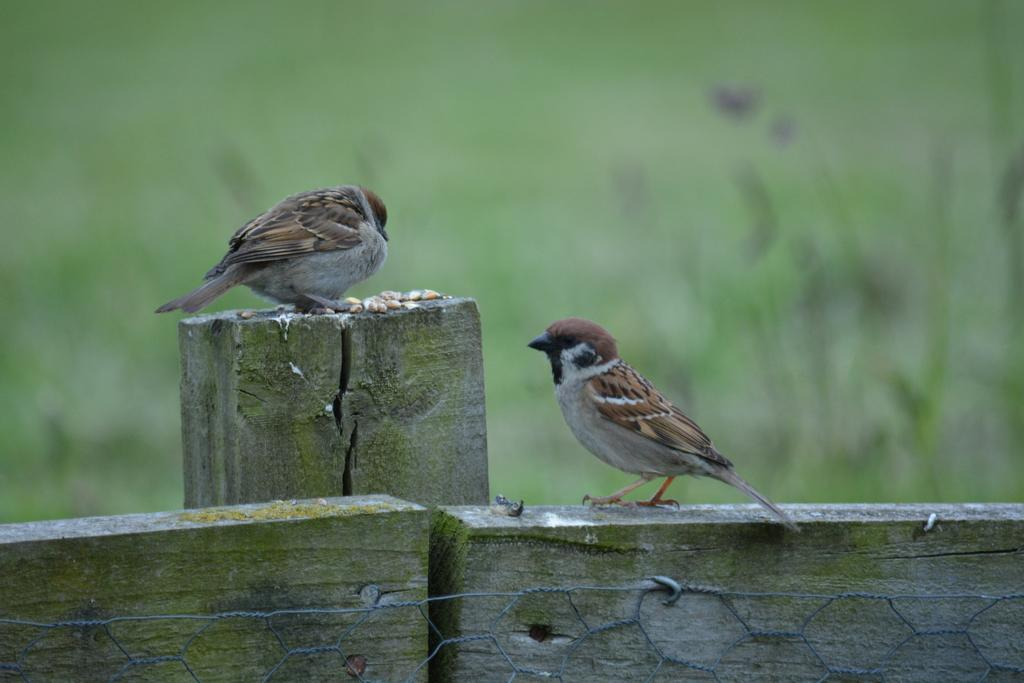How many birds are present in the image? There are two birds in the image. Where are the birds located? The birds are on a wooden fence. Can you describe the background of the image? The background of the image is blurred. What type of drum can be seen in the image? There is no drum present in the image. 